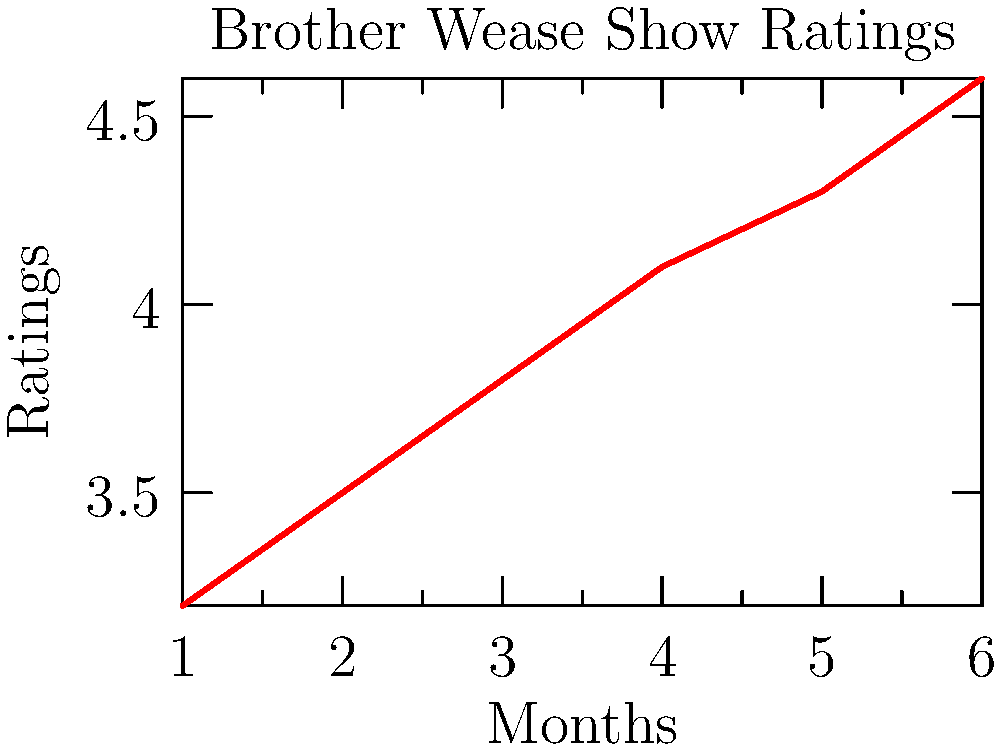Based on the line graph showing Brother Wease's radio show ratings over the past 6 months, what would be the most likely prediction for the show's rating in month 7 if the trend continues? To predict the rating for month 7, we need to analyze the trend in the given data:

1. Observe the pattern: The ratings are consistently increasing each month.

2. Calculate the average increase per month:
   - Total increase: $4.6 - 3.2 = 1.4$
   - Number of intervals: $6 - 1 = 5$
   - Average increase per month: $1.4 / 5 = 0.28$

3. Round the average increase to the nearest tenth: $0.3$

4. Add this increase to the last known rating:
   Month 6 rating: $4.6$
   Predicted Month 7 rating: $4.6 + 0.3 = 4.9$

Therefore, if the trend continues, the most likely prediction for Brother Wease's show rating in month 7 would be 4.9.
Answer: 4.9 